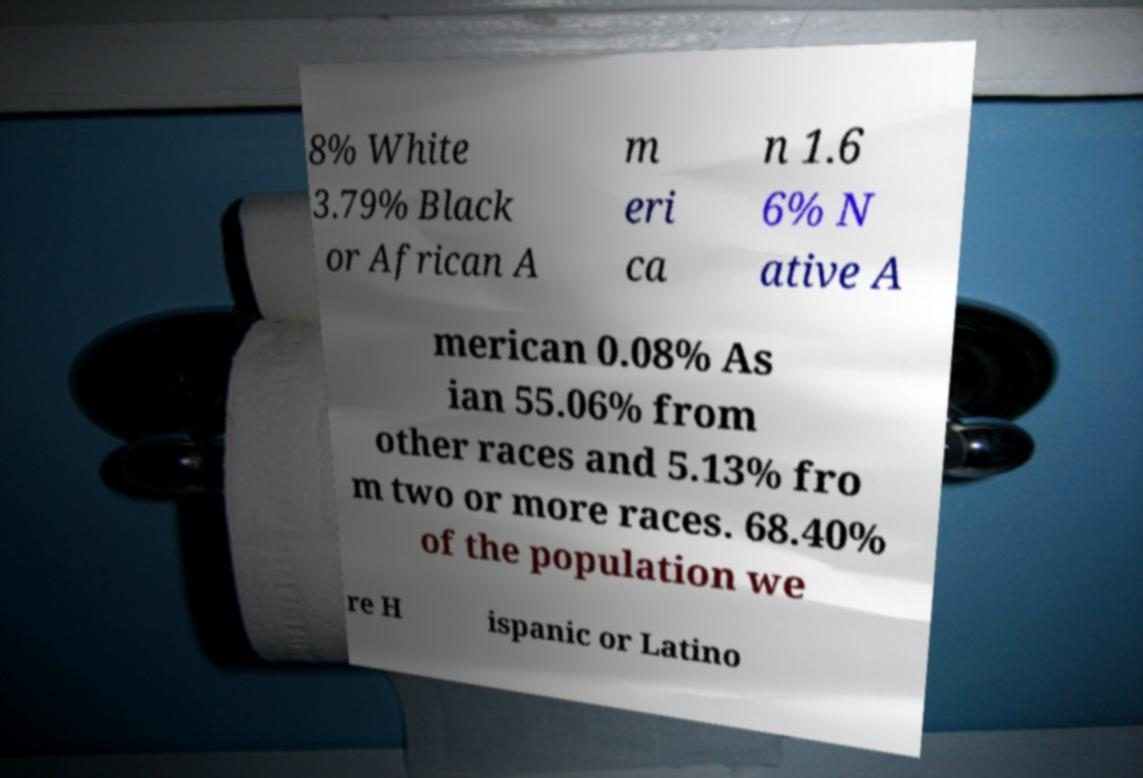For documentation purposes, I need the text within this image transcribed. Could you provide that? 8% White 3.79% Black or African A m eri ca n 1.6 6% N ative A merican 0.08% As ian 55.06% from other races and 5.13% fro m two or more races. 68.40% of the population we re H ispanic or Latino 